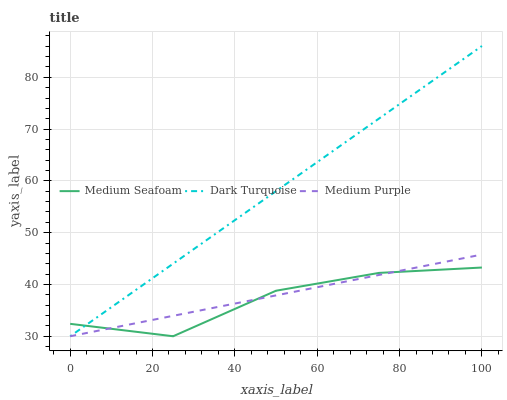Does Medium Seafoam have the minimum area under the curve?
Answer yes or no. Yes. Does Dark Turquoise have the maximum area under the curve?
Answer yes or no. Yes. Does Dark Turquoise have the minimum area under the curve?
Answer yes or no. No. Does Medium Seafoam have the maximum area under the curve?
Answer yes or no. No. Is Medium Purple the smoothest?
Answer yes or no. Yes. Is Medium Seafoam the roughest?
Answer yes or no. Yes. Is Dark Turquoise the smoothest?
Answer yes or no. No. Is Dark Turquoise the roughest?
Answer yes or no. No. Does Medium Purple have the lowest value?
Answer yes or no. Yes. Does Dark Turquoise have the highest value?
Answer yes or no. Yes. Does Medium Seafoam have the highest value?
Answer yes or no. No. Does Medium Purple intersect Dark Turquoise?
Answer yes or no. Yes. Is Medium Purple less than Dark Turquoise?
Answer yes or no. No. Is Medium Purple greater than Dark Turquoise?
Answer yes or no. No. 